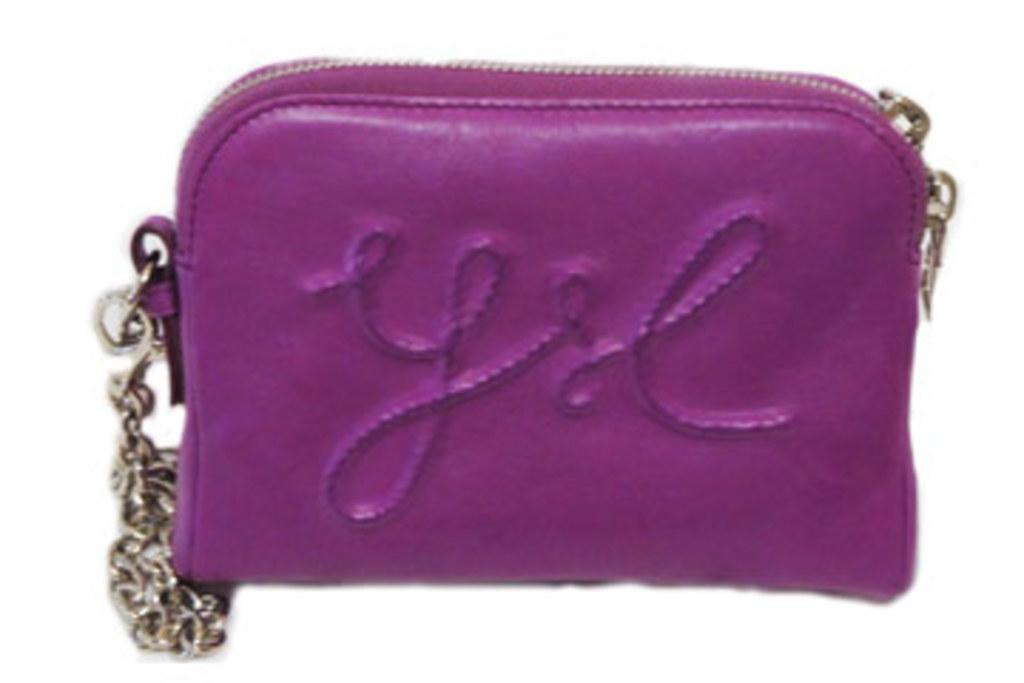Describe this image in one or two sentences. In this picture there is a hand bag with a golden chain, the bag is of purple color. 